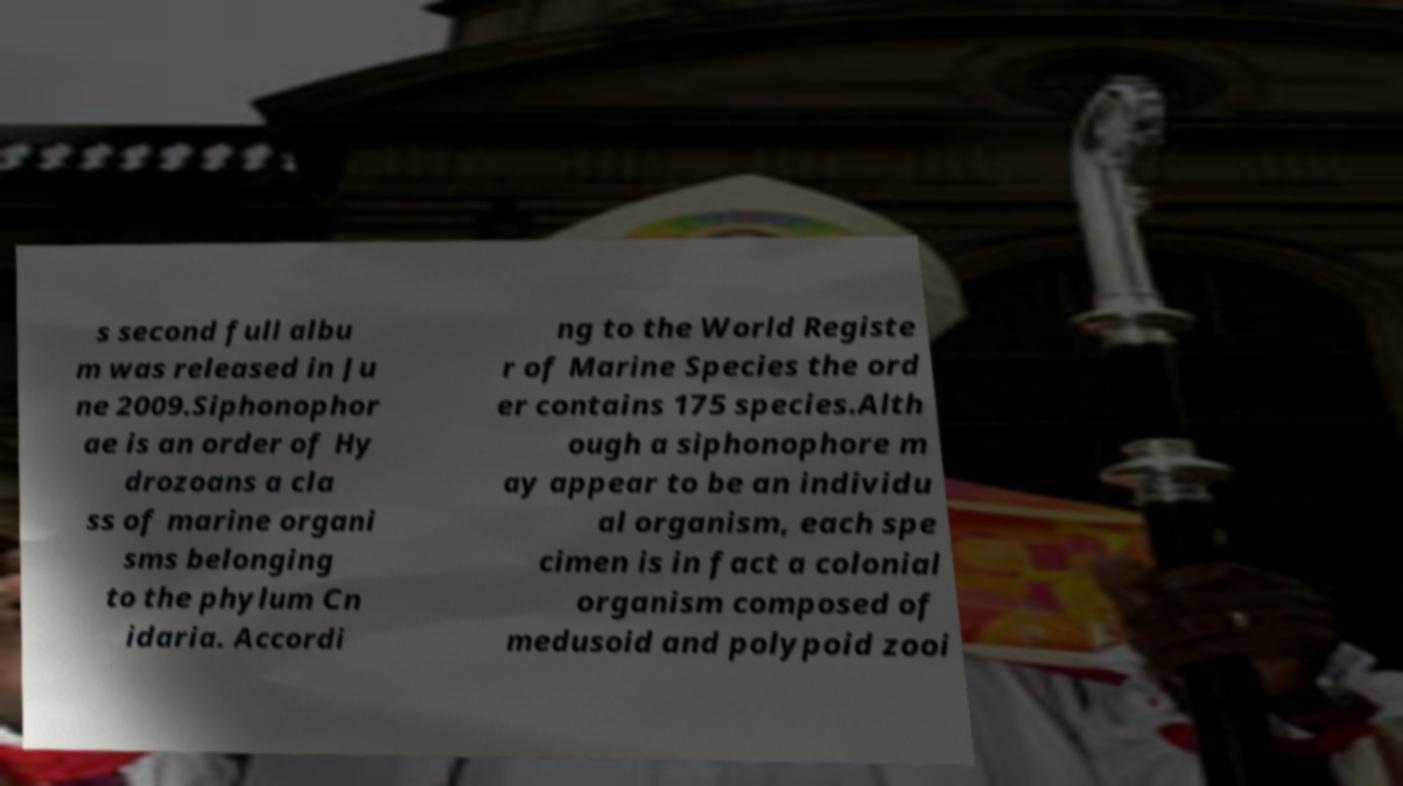Could you extract and type out the text from this image? s second full albu m was released in Ju ne 2009.Siphonophor ae is an order of Hy drozoans a cla ss of marine organi sms belonging to the phylum Cn idaria. Accordi ng to the World Registe r of Marine Species the ord er contains 175 species.Alth ough a siphonophore m ay appear to be an individu al organism, each spe cimen is in fact a colonial organism composed of medusoid and polypoid zooi 